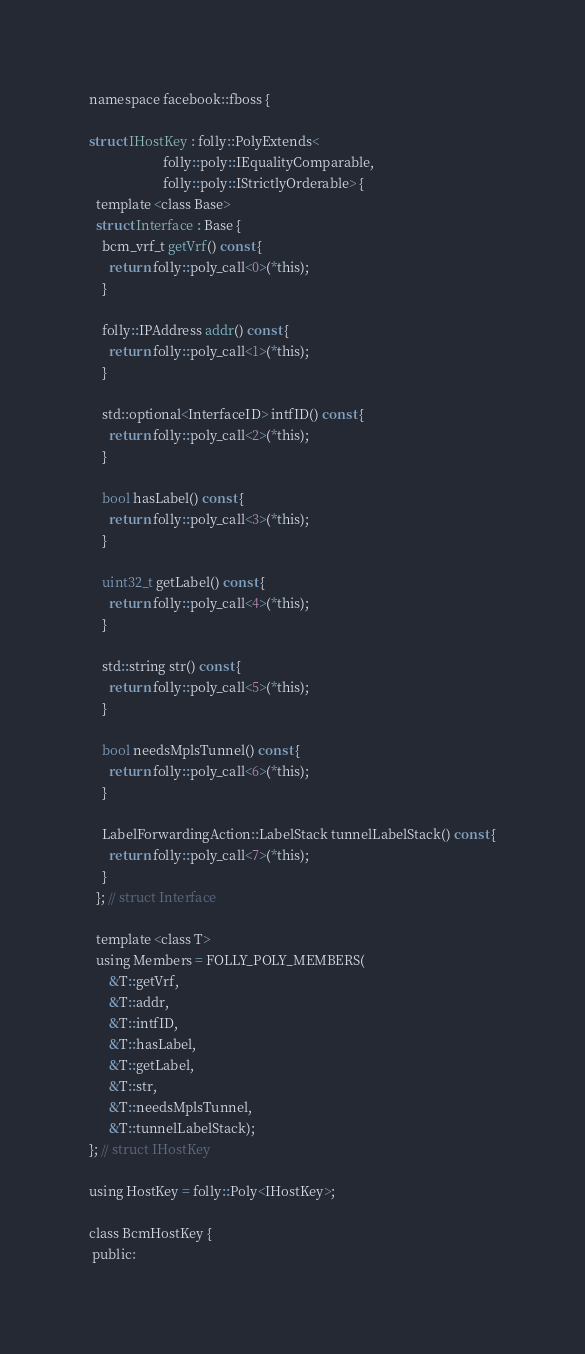Convert code to text. <code><loc_0><loc_0><loc_500><loc_500><_C_>
namespace facebook::fboss {

struct IHostKey : folly::PolyExtends<
                      folly::poly::IEqualityComparable,
                      folly::poly::IStrictlyOrderable> {
  template <class Base>
  struct Interface : Base {
    bcm_vrf_t getVrf() const {
      return folly::poly_call<0>(*this);
    }

    folly::IPAddress addr() const {
      return folly::poly_call<1>(*this);
    }

    std::optional<InterfaceID> intfID() const {
      return folly::poly_call<2>(*this);
    }

    bool hasLabel() const {
      return folly::poly_call<3>(*this);
    }

    uint32_t getLabel() const {
      return folly::poly_call<4>(*this);
    }

    std::string str() const {
      return folly::poly_call<5>(*this);
    }

    bool needsMplsTunnel() const {
      return folly::poly_call<6>(*this);
    }

    LabelForwardingAction::LabelStack tunnelLabelStack() const {
      return folly::poly_call<7>(*this);
    }
  }; // struct Interface

  template <class T>
  using Members = FOLLY_POLY_MEMBERS(
      &T::getVrf,
      &T::addr,
      &T::intfID,
      &T::hasLabel,
      &T::getLabel,
      &T::str,
      &T::needsMplsTunnel,
      &T::tunnelLabelStack);
}; // struct IHostKey

using HostKey = folly::Poly<IHostKey>;

class BcmHostKey {
 public:</code> 